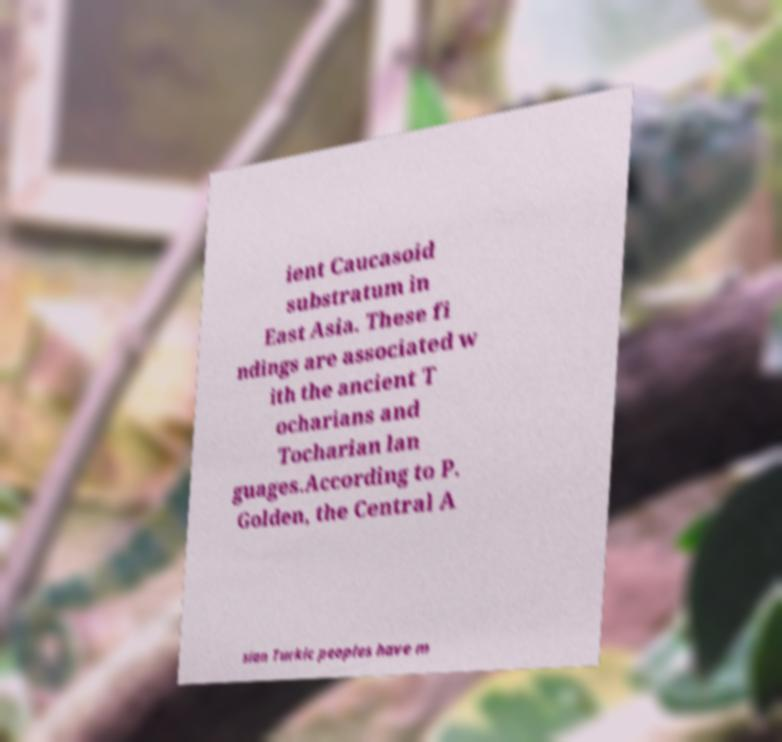Can you read and provide the text displayed in the image?This photo seems to have some interesting text. Can you extract and type it out for me? ient Caucasoid substratum in East Asia. These fi ndings are associated w ith the ancient T ocharians and Tocharian lan guages.According to P. Golden, the Central A sian Turkic peoples have m 